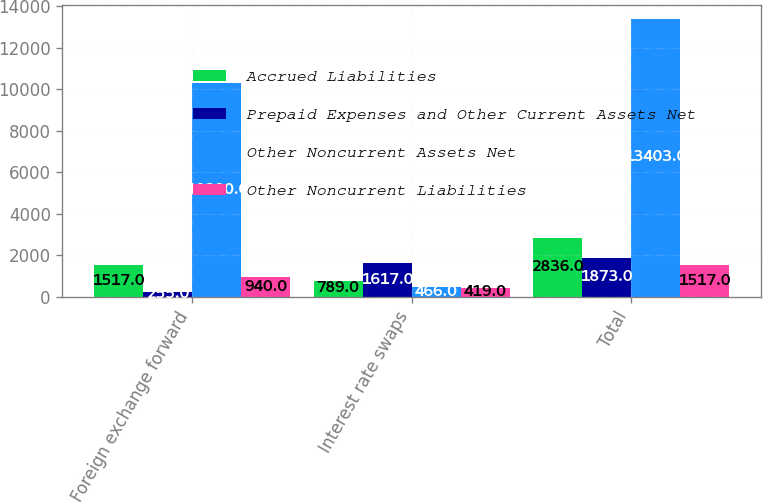<chart> <loc_0><loc_0><loc_500><loc_500><stacked_bar_chart><ecel><fcel>Foreign exchange forward<fcel>Interest rate swaps<fcel>Total<nl><fcel>Accrued Liabilities<fcel>1517<fcel>789<fcel>2836<nl><fcel>Prepaid Expenses and Other Current Assets Net<fcel>255<fcel>1617<fcel>1873<nl><fcel>Other Noncurrent Assets Net<fcel>10280<fcel>466<fcel>13403<nl><fcel>Other Noncurrent Liabilities<fcel>940<fcel>419<fcel>1517<nl></chart> 